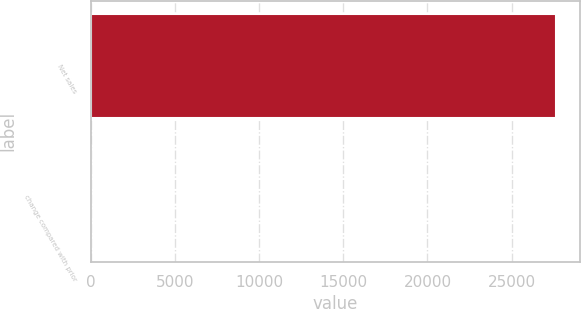<chart> <loc_0><loc_0><loc_500><loc_500><bar_chart><fcel>Net sales<fcel>change compared with prior<nl><fcel>27653<fcel>8<nl></chart> 